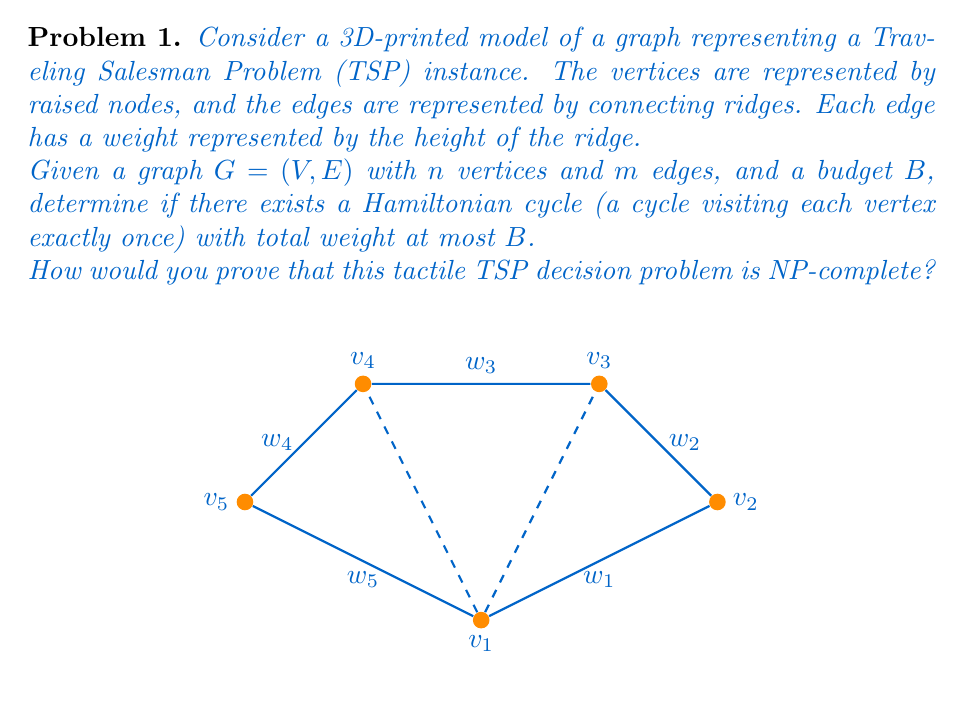Can you solve this math problem? To prove that the tactile TSP decision problem is NP-complete, we need to show that it is both in NP and NP-hard.

1. Prove the problem is in NP:
   - A solution to the problem is a Hamiltonian cycle in the graph.
   - We can verify a solution in polynomial time by:
     a) Checking if the cycle visits each vertex exactly once (O(n) time).
     b) Calculating the total weight of the cycle and comparing it to B (O(n) time).
   - Thus, the problem is in NP.

2. Prove the problem is NP-hard:
   - We can reduce the standard TSP decision problem (known to be NP-complete) to our tactile TSP problem.
   - The reduction is straightforward:
     a) For each vertex in the standard TSP, create a raised node in the 3D model.
     b) For each edge in the standard TSP, create a connecting ridge in the 3D model.
     c) Set the height of each ridge to represent the weight of the corresponding edge.
     d) Use the same budget B for both problems.
   - This reduction is polynomial-time computable.
   - If we can solve the tactile TSP problem, we can solve the standard TSP problem.

3. Conclusion:
   - Since the problem is both in NP and NP-hard, it is NP-complete.

The tactile representation does not change the computational complexity of the problem. It merely provides an alternative way to represent the problem that can be perceived through touch, making it accessible to visually impaired individuals.

The 3D-printed model allows for tactile exploration of the graph structure and edge weights, but the underlying problem remains NP-complete. This demonstrates that even when we change the representation of a problem to make it more accessible, its fundamental computational complexity can remain unchanged.
Answer: NP-complete 